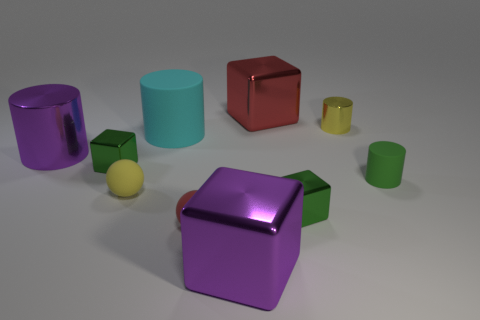Subtract all cyan balls. Subtract all cyan cylinders. How many balls are left? 2 Subtract all cylinders. How many objects are left? 6 Add 9 yellow rubber objects. How many yellow rubber objects exist? 10 Subtract 0 cyan spheres. How many objects are left? 10 Subtract all small yellow things. Subtract all red rubber spheres. How many objects are left? 7 Add 4 large cyan matte cylinders. How many large cyan matte cylinders are left? 5 